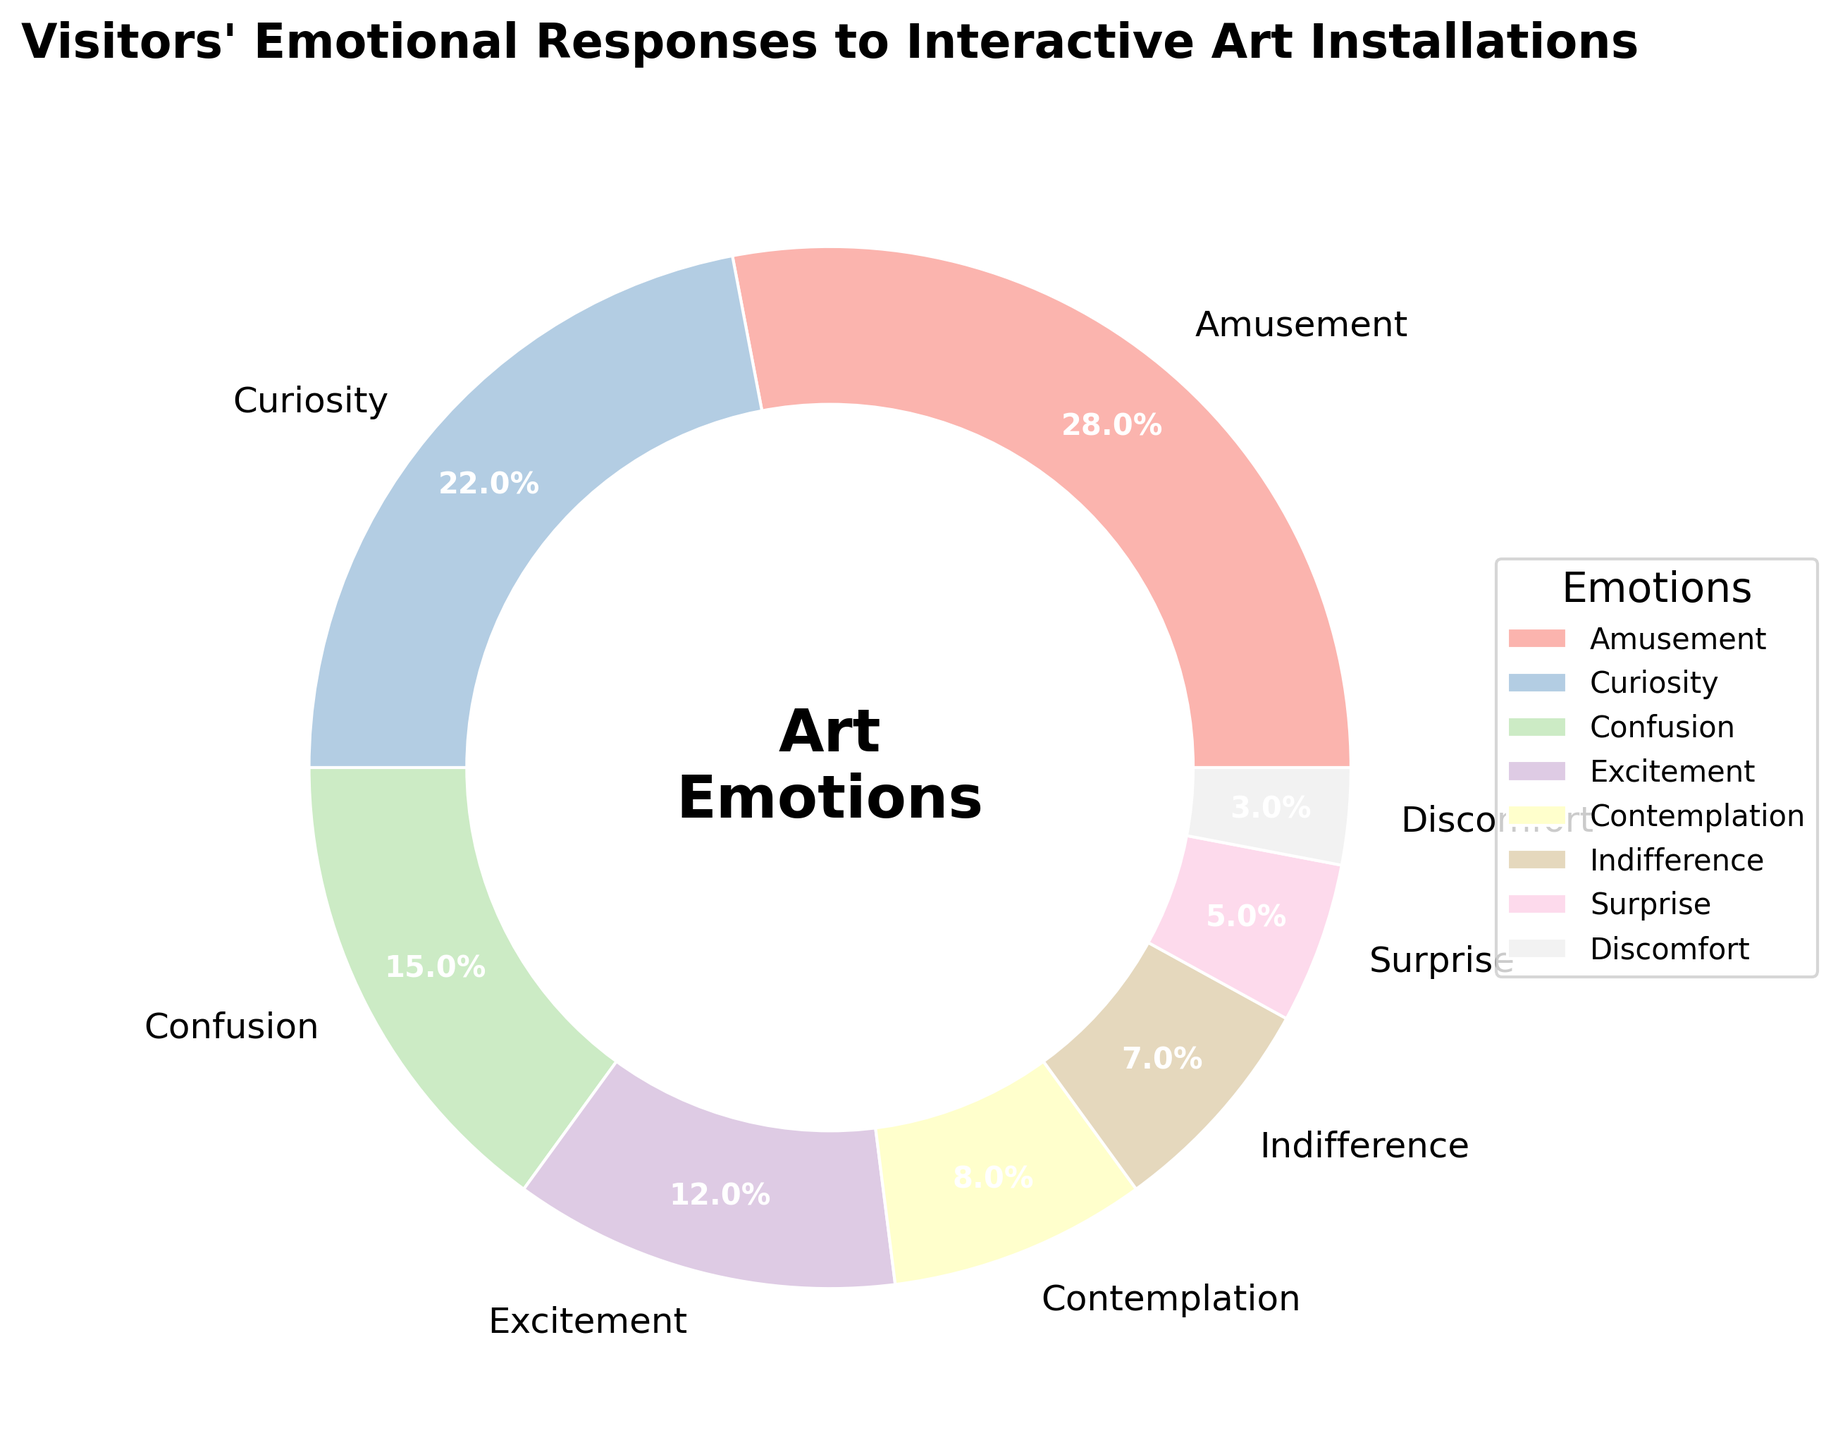Which emotion has the highest percentage? The wedge with the label "Amusement" has the largest size and the percentage text "28.0%".
Answer: Amusement What is the combined percentage of curiosity and contemplation? The percentage for curiosity is 22.0% and for contemplation is 8.0%. Adding them together, 22.0% + 8.0% = 30.0%.
Answer: 30.0% Which emotion is the least common among the visitors? The smallest wedge is labeled "Discomfort" with a percentage of 3.0%.
Answer: Discomfort How much more common is excitement compared to indifference? The percentage for excitement is 12.0% and for indifference is 7.0%. Subtracting them, 12.0% - 7.0% = 5.0%.
Answer: 5.0% Are there any emotions that have a percentage greater than 20%? The wedges for "Amusement" and "Curiosity" have percentages of 28.0% and 22.0% respectively, both are greater than 20%.
Answer: Yes How do the combined percentages of surprise and discomfort compare to confusion? The percentage for surprise is 5.0% and for discomfort is 3.0%; their sum is 5.0% + 3.0% = 8.0%. The percentage for confusion is 15.0%. 8.0% (combined) is less than 15.0%.
Answer: Less What is the difference in percentage between curiosity and indifference? The percentage for curiosity is 22.0% and for indifference is 7.0%. Subtracting the latter from the former, 22.0% - 7.0% = 15.0%.
Answer: 15.0% What percentage of visitors did not feel amusement, curiosity, or confusion? Summing amusement (28.0%), curiosity (22.0%), and confusion (15.0%) gives 65.0%. Subtracting from 100%, 100% - 65.0% = 35.0%.
Answer: 35.0% Which emotions combined make up less than 20% of the responses? The percentages are: Contemplation (8.0%), Indifference (7.0%), Surprise (5.0%), and Discomfort (3.0%). Summing 8.0% + 7.0% + 5.0% + 3.0% = 23.0%, all four together do not fit. So, smaller combinations must be considered:
  - Surprise (5.0%), and Discomfort (3.0%) sum to 8.0%.
  - Indifference, Surprise sum to 12.0%.
  - Contemplation, Surprise sum to 13.0%.
  - Indifference and Discomfort sum to 10.0%.
Therefore, contemplation alone, indifference alone, and surprise alone or with discomfort, surprise and discomfort together fit.
Answer: Contemplation, Indifference, Surprise, Discomfort 